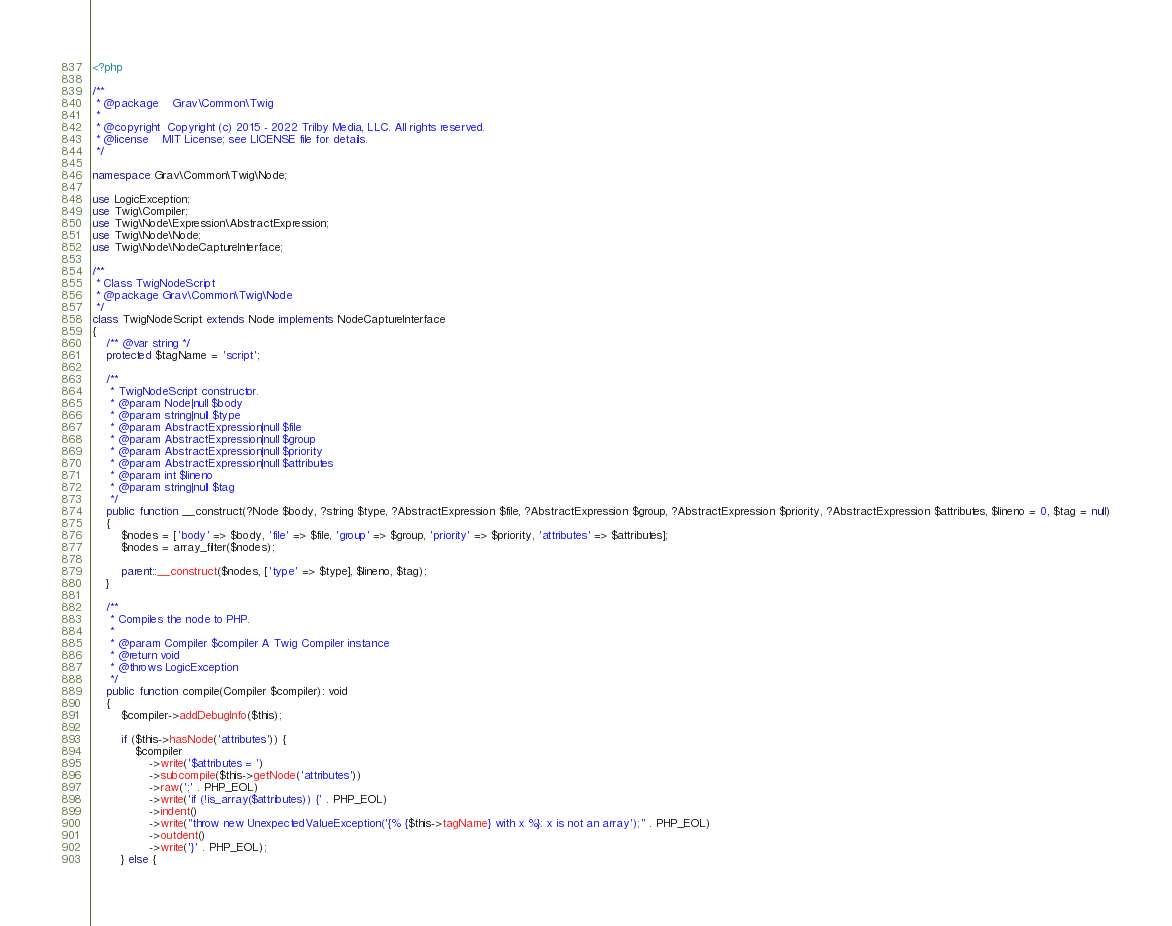Convert code to text. <code><loc_0><loc_0><loc_500><loc_500><_PHP_><?php

/**
 * @package    Grav\Common\Twig
 *
 * @copyright  Copyright (c) 2015 - 2022 Trilby Media, LLC. All rights reserved.
 * @license    MIT License; see LICENSE file for details.
 */

namespace Grav\Common\Twig\Node;

use LogicException;
use Twig\Compiler;
use Twig\Node\Expression\AbstractExpression;
use Twig\Node\Node;
use Twig\Node\NodeCaptureInterface;

/**
 * Class TwigNodeScript
 * @package Grav\Common\Twig\Node
 */
class TwigNodeScript extends Node implements NodeCaptureInterface
{
    /** @var string */
    protected $tagName = 'script';

    /**
     * TwigNodeScript constructor.
     * @param Node|null $body
     * @param string|null $type
     * @param AbstractExpression|null $file
     * @param AbstractExpression|null $group
     * @param AbstractExpression|null $priority
     * @param AbstractExpression|null $attributes
     * @param int $lineno
     * @param string|null $tag
     */
    public function __construct(?Node $body, ?string $type, ?AbstractExpression $file, ?AbstractExpression $group, ?AbstractExpression $priority, ?AbstractExpression $attributes, $lineno = 0, $tag = null)
    {
        $nodes = ['body' => $body, 'file' => $file, 'group' => $group, 'priority' => $priority, 'attributes' => $attributes];
        $nodes = array_filter($nodes);

        parent::__construct($nodes, ['type' => $type], $lineno, $tag);
    }

    /**
     * Compiles the node to PHP.
     *
     * @param Compiler $compiler A Twig Compiler instance
     * @return void
     * @throws LogicException
     */
    public function compile(Compiler $compiler): void
    {
        $compiler->addDebugInfo($this);

        if ($this->hasNode('attributes')) {
            $compiler
                ->write('$attributes = ')
                ->subcompile($this->getNode('attributes'))
                ->raw(';' . PHP_EOL)
                ->write('if (!is_array($attributes)) {' . PHP_EOL)
                ->indent()
                ->write("throw new UnexpectedValueException('{% {$this->tagName} with x %}: x is not an array');" . PHP_EOL)
                ->outdent()
                ->write('}' . PHP_EOL);
        } else {</code> 